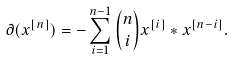<formula> <loc_0><loc_0><loc_500><loc_500>\partial ( x ^ { [ n ] } ) = - \sum _ { i = 1 } ^ { n - 1 } { n \choose i } x ^ { [ i ] } * x ^ { [ n - i ] } .</formula> 